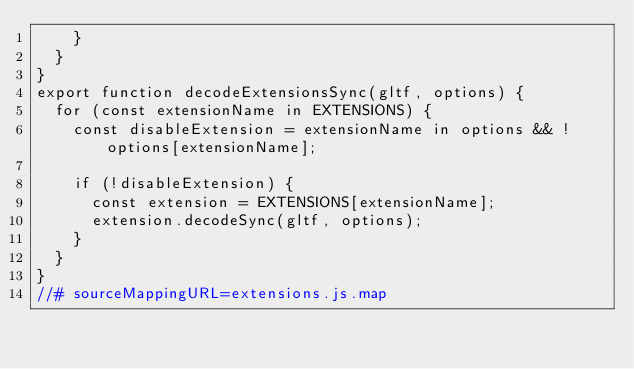<code> <loc_0><loc_0><loc_500><loc_500><_JavaScript_>    }
  }
}
export function decodeExtensionsSync(gltf, options) {
  for (const extensionName in EXTENSIONS) {
    const disableExtension = extensionName in options && !options[extensionName];

    if (!disableExtension) {
      const extension = EXTENSIONS[extensionName];
      extension.decodeSync(gltf, options);
    }
  }
}
//# sourceMappingURL=extensions.js.map</code> 